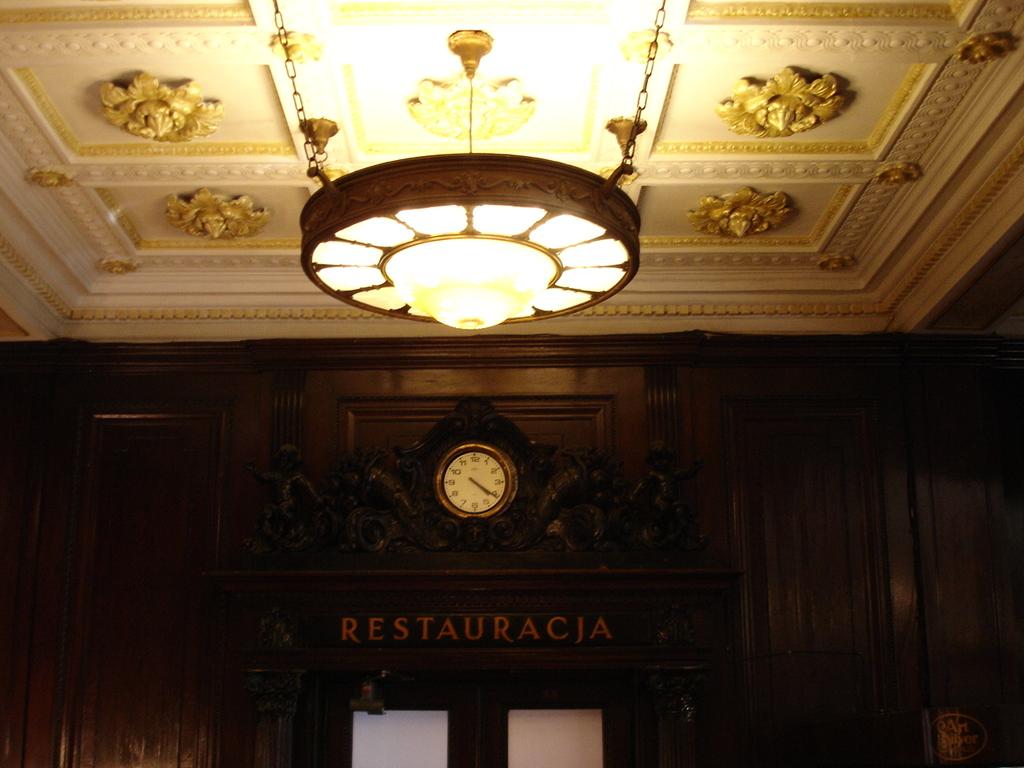What time is it?
Provide a short and direct response. 4:20. 